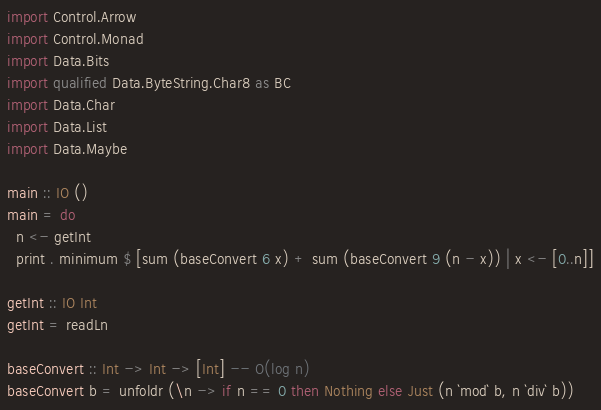Convert code to text. <code><loc_0><loc_0><loc_500><loc_500><_Haskell_>import Control.Arrow
import Control.Monad
import Data.Bits
import qualified Data.ByteString.Char8 as BC
import Data.Char
import Data.List
import Data.Maybe

main :: IO ()
main = do
  n <- getInt
  print . minimum $ [sum (baseConvert 6 x) + sum (baseConvert 9 (n - x)) | x <- [0..n]]

getInt :: IO Int
getInt = readLn

baseConvert :: Int -> Int -> [Int] -- O(log n)
baseConvert b = unfoldr (\n -> if n == 0 then Nothing else Just (n `mod` b, n `div` b))
</code> 